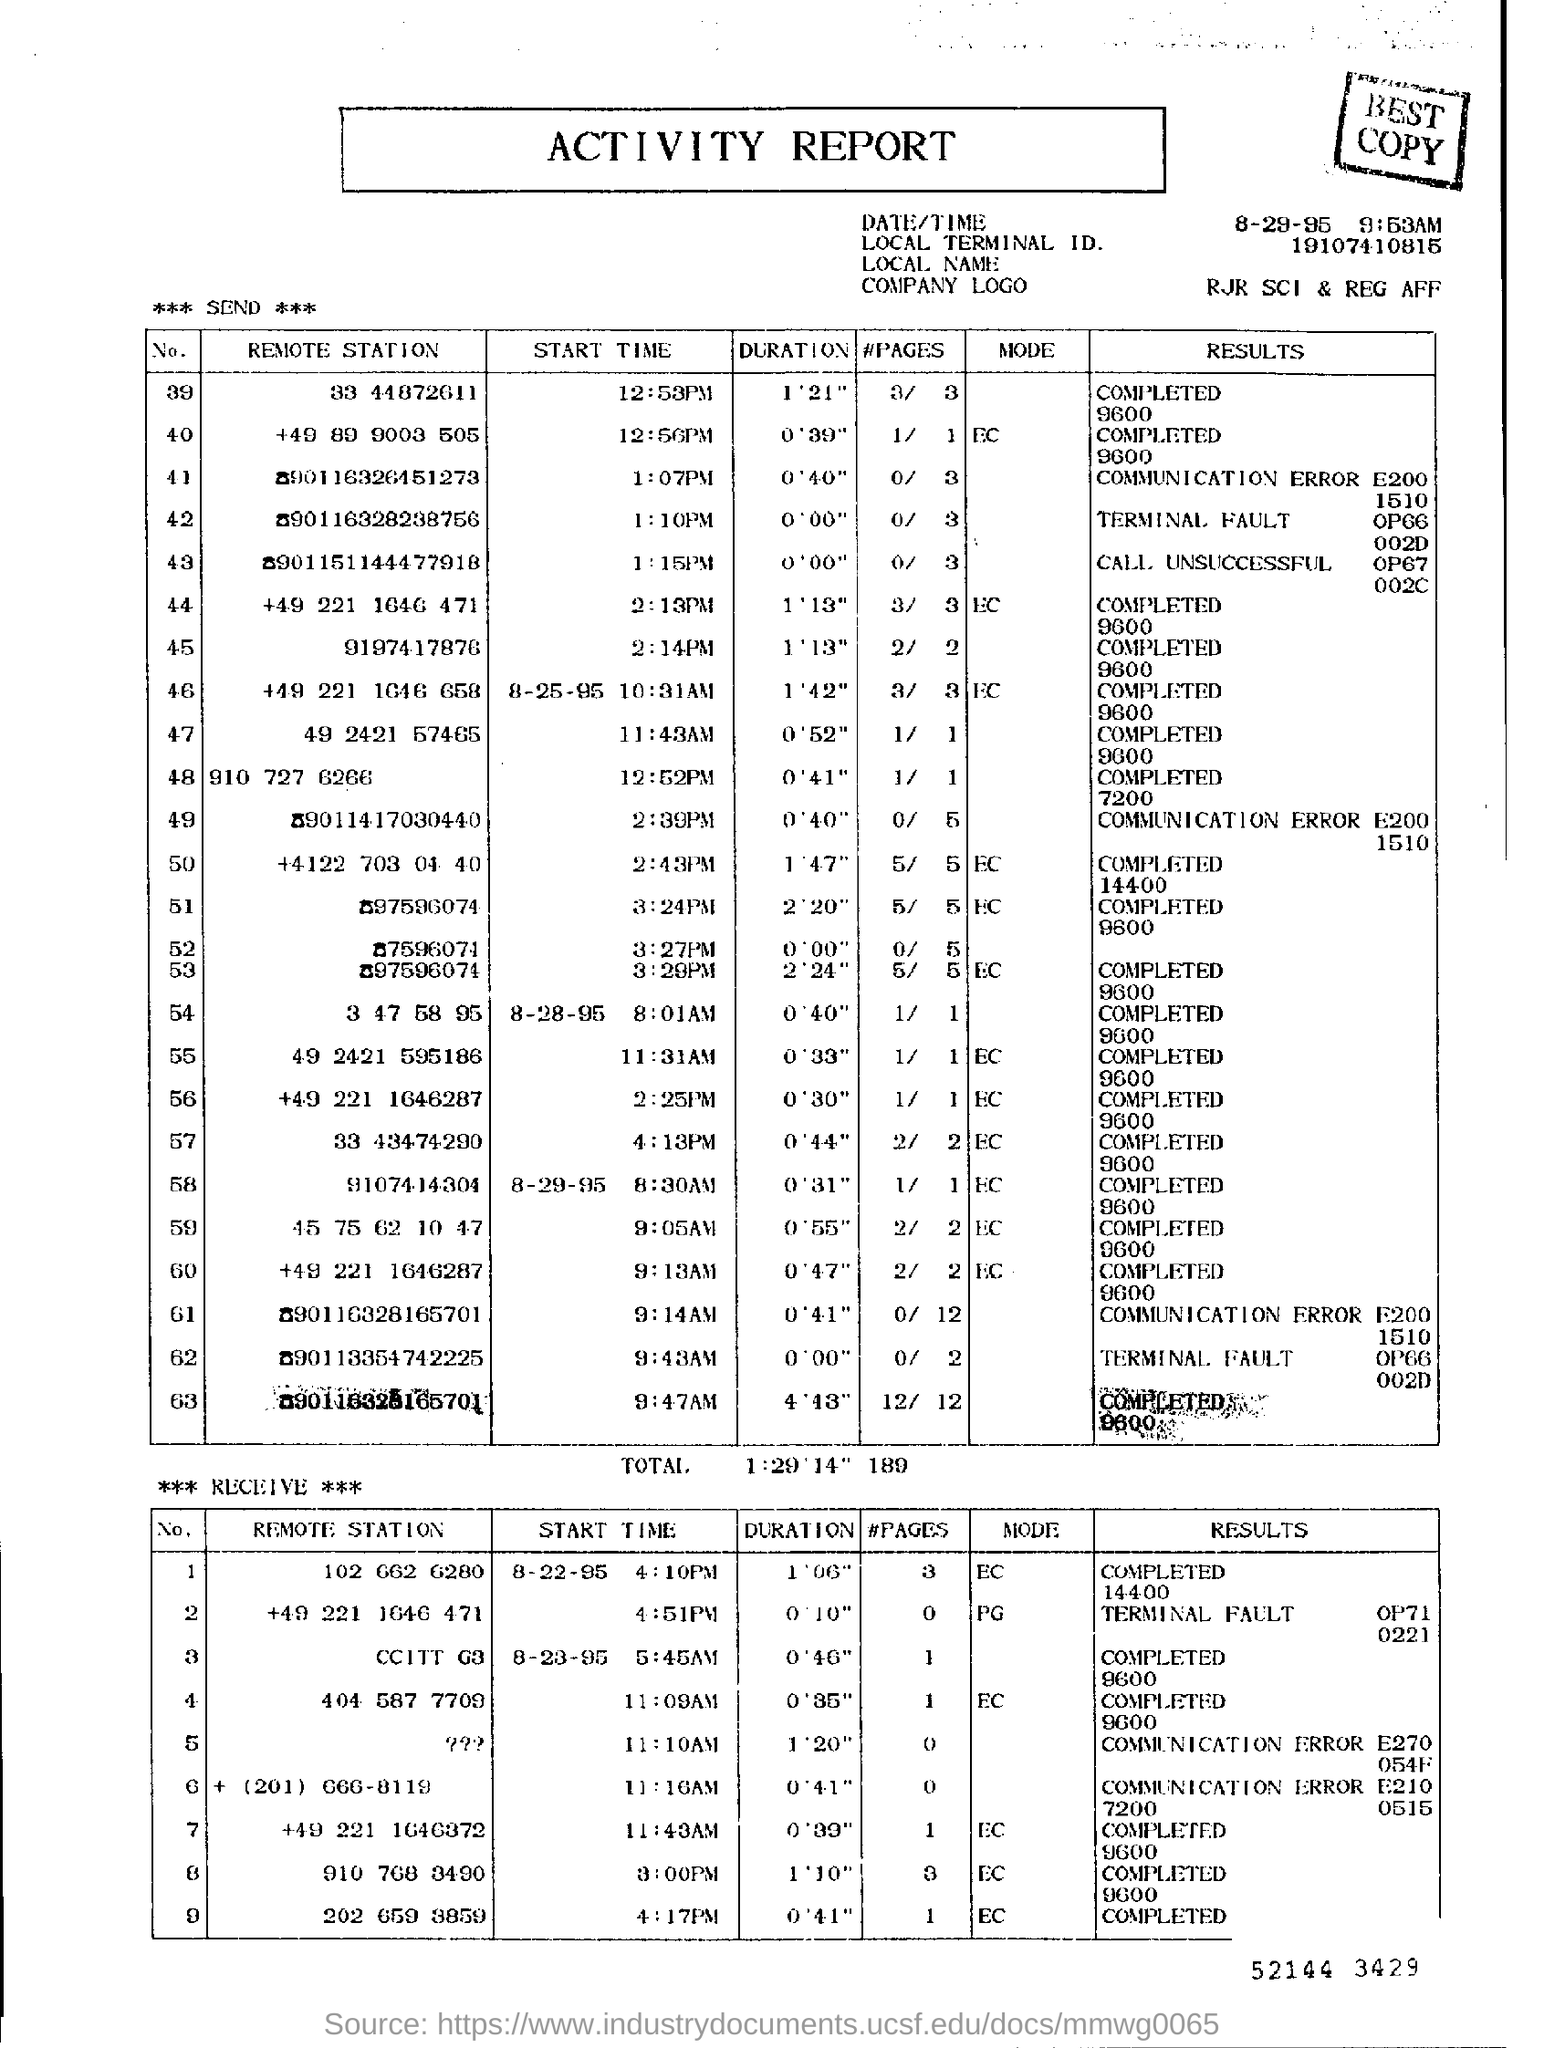Point out several critical features in this image. This document is an activity report. The Local Terminal ID mentioned in the report is 19107410815. 